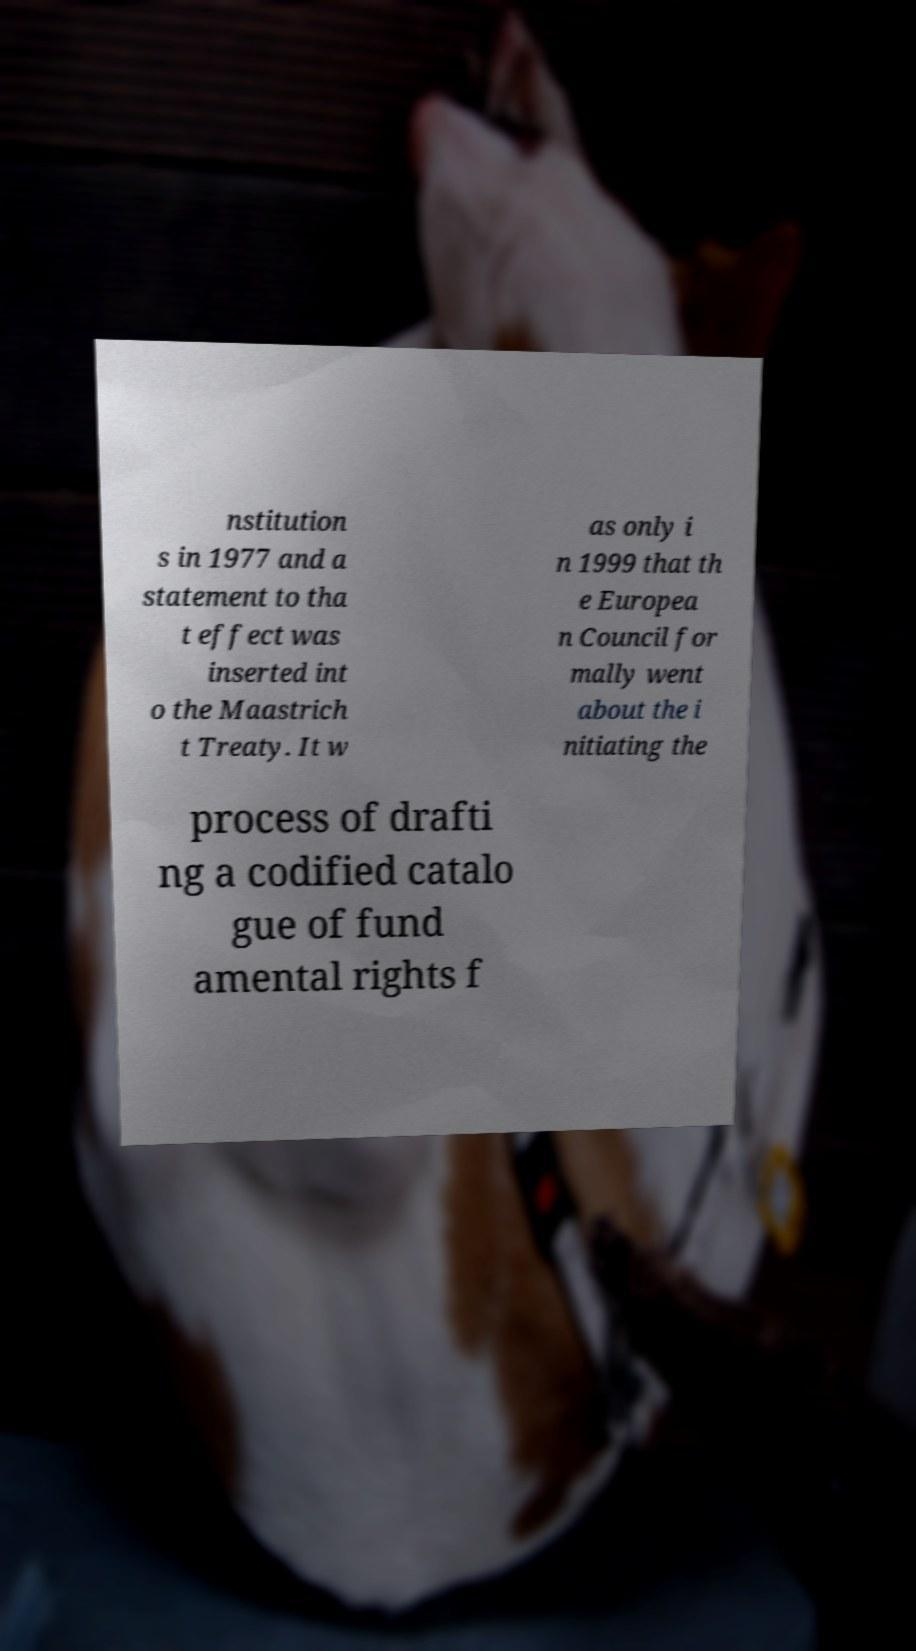Please read and relay the text visible in this image. What does it say? nstitution s in 1977 and a statement to tha t effect was inserted int o the Maastrich t Treaty. It w as only i n 1999 that th e Europea n Council for mally went about the i nitiating the process of drafti ng a codified catalo gue of fund amental rights f 